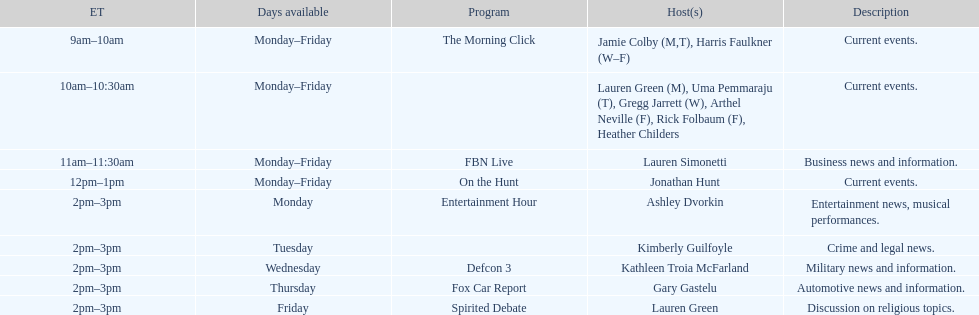What is the count of programs that feature a single host daily? 7. 